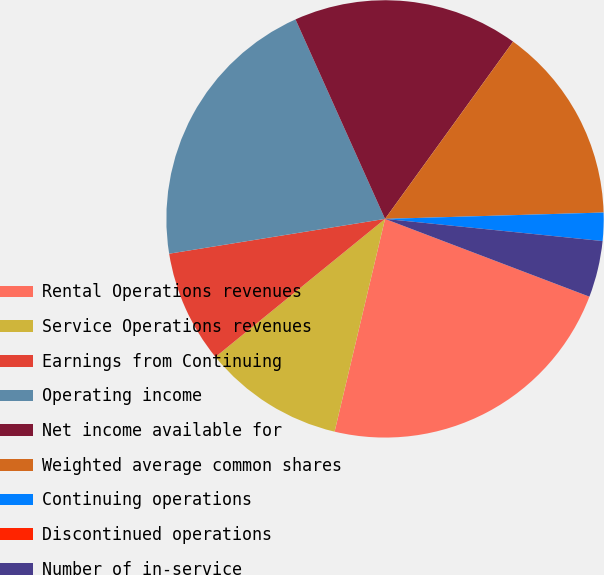<chart> <loc_0><loc_0><loc_500><loc_500><pie_chart><fcel>Rental Operations revenues<fcel>Service Operations revenues<fcel>Earnings from Continuing<fcel>Operating income<fcel>Net income available for<fcel>Weighted average common shares<fcel>Continuing operations<fcel>Discontinued operations<fcel>Number of in-service<nl><fcel>22.92%<fcel>10.42%<fcel>8.33%<fcel>20.83%<fcel>16.67%<fcel>14.58%<fcel>2.08%<fcel>0.0%<fcel>4.17%<nl></chart> 